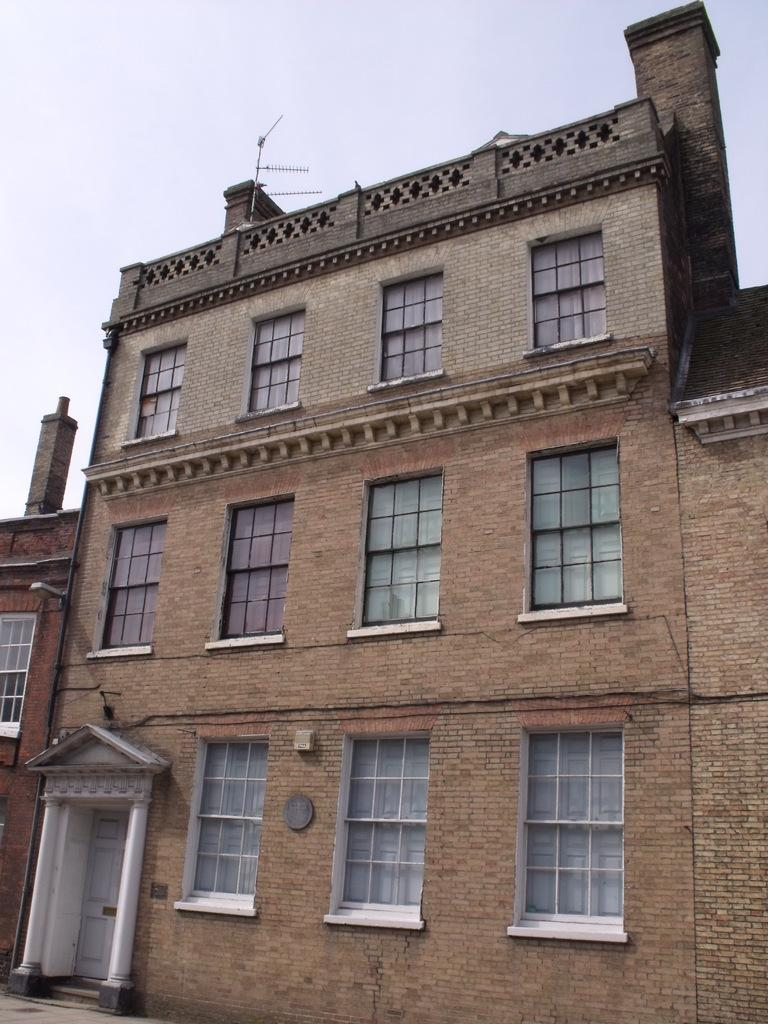What type of structures are present in the image? There are buildings in the image. What features can be seen on the buildings? The buildings have doors and windows. What is visible at the top of the image? The sky is visible at the top of the image. What type of drink is being served in the buildings in the image? There is no indication of any drinks being served in the image; it only shows buildings with doors and windows. 